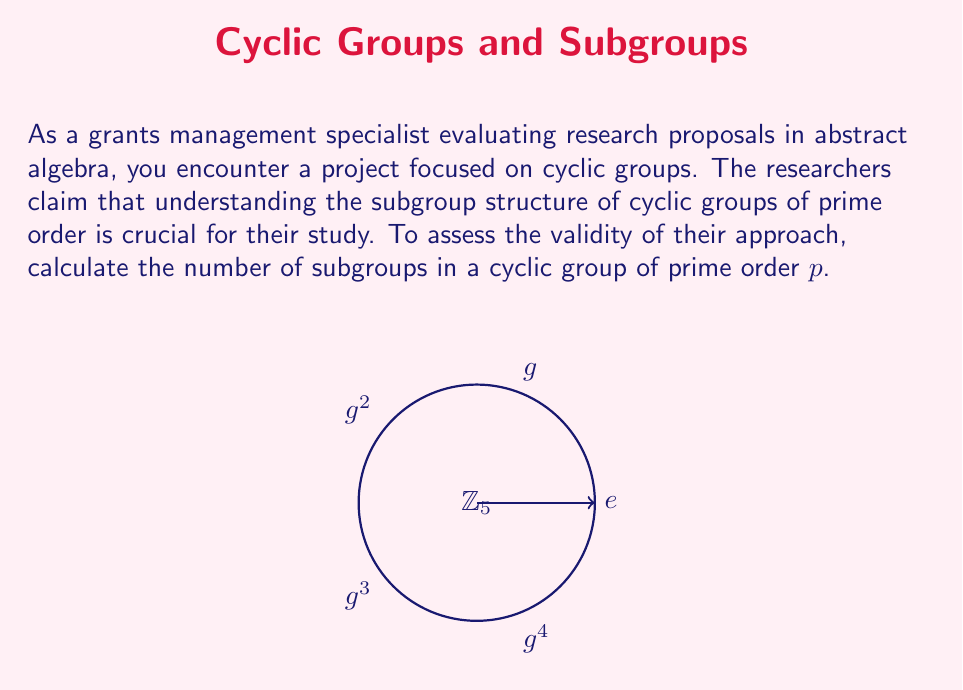Help me with this question. To determine the number of subgroups in a cyclic group of prime order $p$, let's follow these steps:

1) First, recall that a cyclic group of order $p$ is isomorphic to the additive group $\mathbb{Z}_p$ (integers modulo $p$).

2) In a cyclic group $G = \langle g \rangle$ of order $p$, the elements are:
   $G = \{e, g, g^2, ..., g^{p-1}\}$

3) For any subgroup $H$ of $G$, we know from Lagrange's Theorem that $|H|$ must divide $|G| = p$.

4) Since $p$ is prime, the only divisors of $p$ are 1 and $p$ itself.

5) This means that the only possible orders for subgroups of $G$ are:
   - Order 1: the trivial subgroup $\{e\}$
   - Order $p$: the entire group $G$

6) There is exactly one subgroup of order 1 (the trivial subgroup).

7) There is exactly one subgroup of order $p$ (the entire group $G$).

8) Therefore, the total number of subgroups is 1 + 1 = 2.

This result is consistent regardless of the specific prime $p$, making it a fundamental property of cyclic groups of prime order.
Answer: 2 